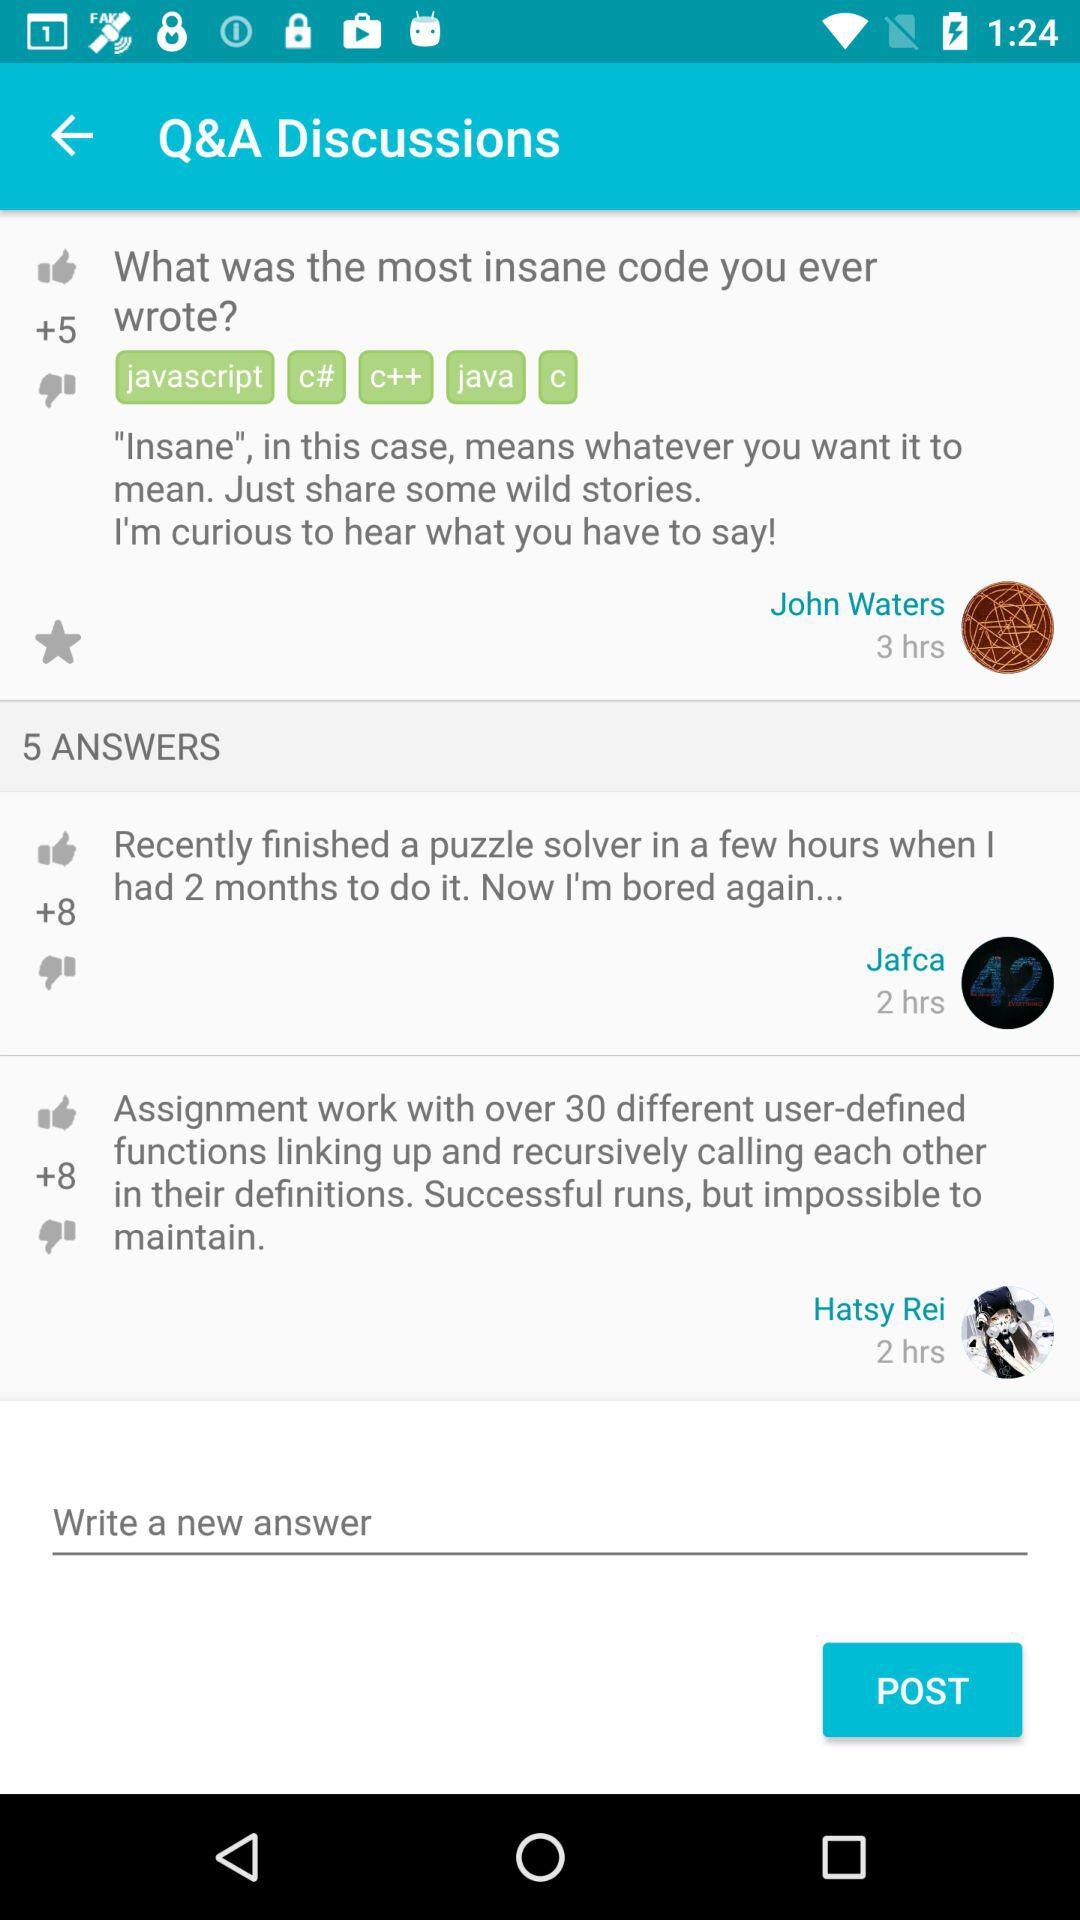How many answers are there? There are 5 answers. 